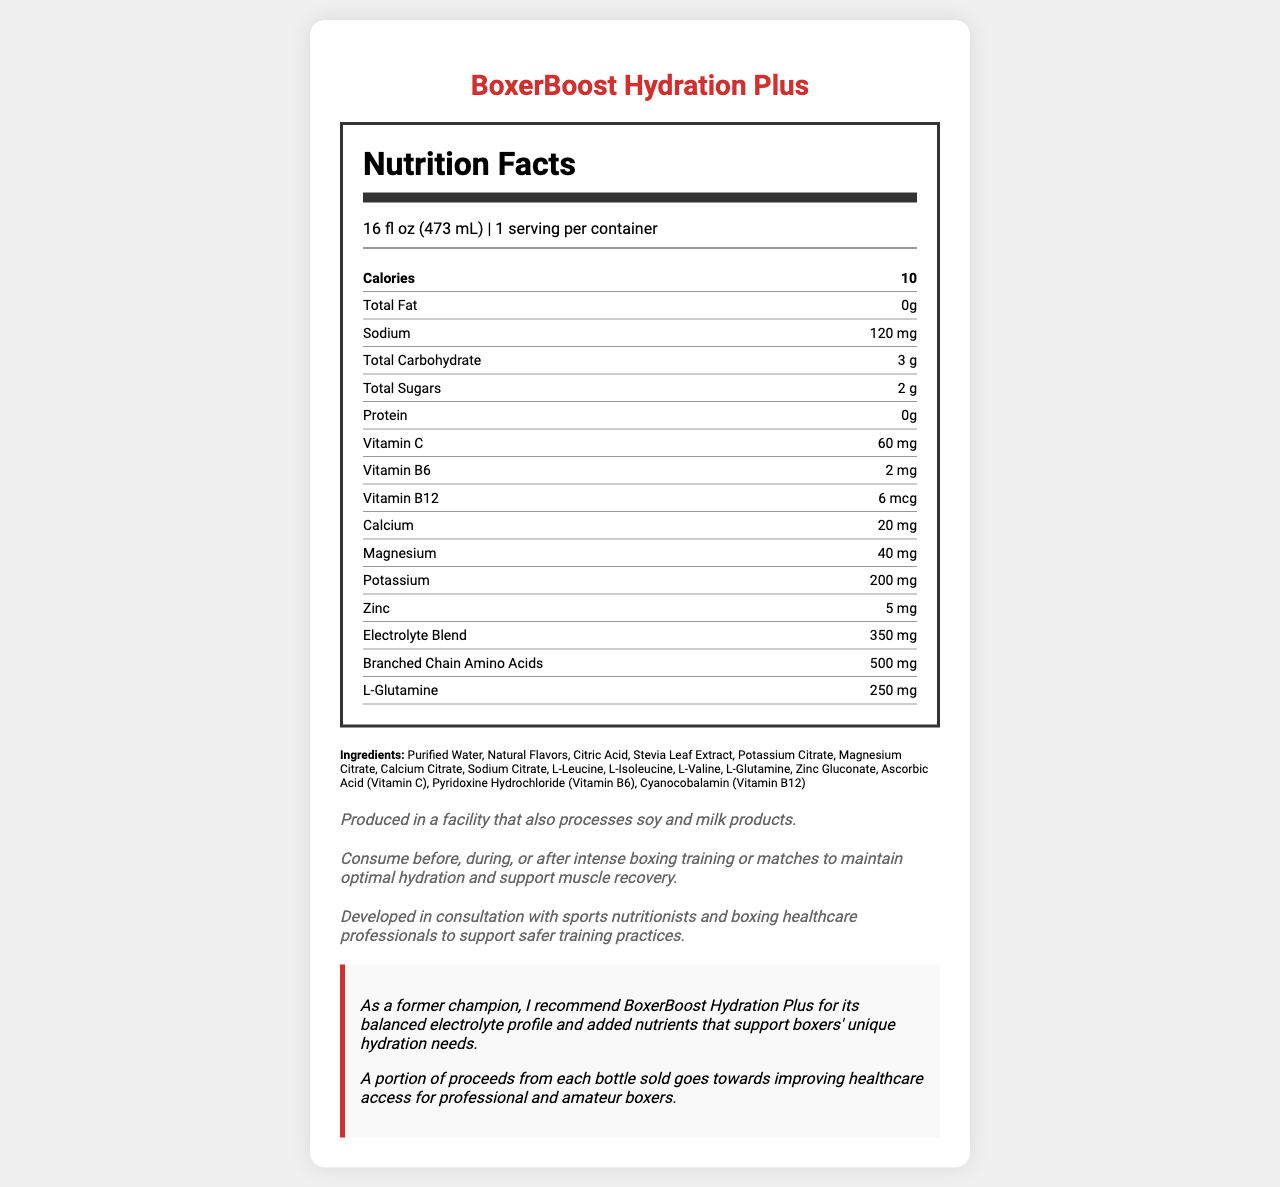what is the product name? The product name is clearly labeled at the top of the document as "BoxerBoost Hydration Plus".
Answer: BoxerBoost Hydration Plus how many servings are in one container? The document states "1 serving per container".
Answer: 1 how many calories are in one serving? The number of calories is listed as "10" in the nutrition facts section.
Answer: 10 what is the amount of sodium in one serving? Under the nutrient "Sodium", it lists the amount as "120 mg".
Answer: 120 mg which vitamins are included in the product? The vitamins listed in the nutrient section include Vitamin C (60 mg), Vitamin B6 (2 mg), and Vitamin B12 (6 mcg).
Answer: Vitamin C, Vitamin B6, Vitamin B12 where is this product produced? A. In a facility that processes soy products B. In a facility that processes milk products C. In a facility that processes both soy and milk products D. In a facility that processes neither soy nor milk products The allergen information states that it is produced in a facility that also processes both soy and milk products.
Answer: C how many grams of total carbohydrates does the product have? "Total Carbohydrate" is listed with an amount of "3 g".
Answer: 3 g what is the total amount of sugars per serving? The document mentions "Total Sugars" as "2 g".
Answer: 2 g how much protein does the product contain? A. 0 g B. 5 g C. 10 g D. 20 g The amount of protein is stated as "0 g".
Answer: A does the product contain any fat? The document lists "Total Fat" as "0 g".
Answer: No who endorses the product? The document includes a champion endorsement section recommending the product and mentions it is endorsed by a former champion.
Answer: A former champion when should this product be consumed? The usage instructions suggest consuming the product before, during, or after intense boxing training or matches for optimal hydration and muscle recovery.
Answer: Before, during, or after intense boxing training or matches what is the calorie content of the product? The calorie content is labeled as "10".
Answer: 10 calories how much calcium is in the product? The nutritional section lists "Calcium" with an amount of "20 mg".
Answer: 20 mg is the product recommended for muscle recovery? The usage instructions mention that it supports muscle recovery.
Answer: Yes what do the proceeds from each bottle go towards? The health advocacy statement explains that proceeds are used to improve healthcare access for boxers.
Answer: Improving healthcare access for professional and amateur boxers describe the main idea of the document The document is centered around presenting BoxerBoost Hydration Plus, outlining its nutritional benefits, ingredients, and usage recommendations while emphasizing its endorsement and advocacy for boxers' health.
Answer: The document provides detailed nutritional information about BoxerBoost Hydration Plus, a hydration drink specifically formulated for boxers. It highlights the ingredients, serving size, nutrient content, and usage instructions. It also includes endorsements from a former champion and notes on proceeds supporting healthcare access for boxers. how much electrolytes are in the product? The nutrition label lists "Electrolyte Blend" as "350 mg".
Answer: 350 mg can this document provide details on how the product was developed? The safety note mentions that the product was developed in consultation with sports nutritionists and boxing healthcare professionals.
Answer: Yes what is the purpose of the stevia leaf extract in the ingredients list? The document lists stevia leaf extract as an ingredient but does not provide information on its specific purpose within the product.
Answer: I don't know 